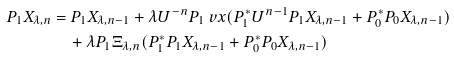<formula> <loc_0><loc_0><loc_500><loc_500>P _ { 1 } X _ { \lambda , n } & = P _ { 1 } X _ { \lambda , n - 1 } + \lambda { U } ^ { - n } P _ { 1 } \ v x ( P _ { 1 } ^ { * } U ^ { n - 1 } P _ { 1 } X _ { \lambda , n - 1 } + P _ { 0 } ^ { * } P _ { 0 } X _ { \lambda , n - 1 } ) \\ & \quad + \lambda P _ { 1 } \Xi _ { \lambda , n } ( P _ { 1 } ^ { * } P _ { 1 } X _ { \lambda , n - 1 } + P _ { 0 } ^ { * } P _ { 0 } X _ { \lambda , n - 1 } )</formula> 